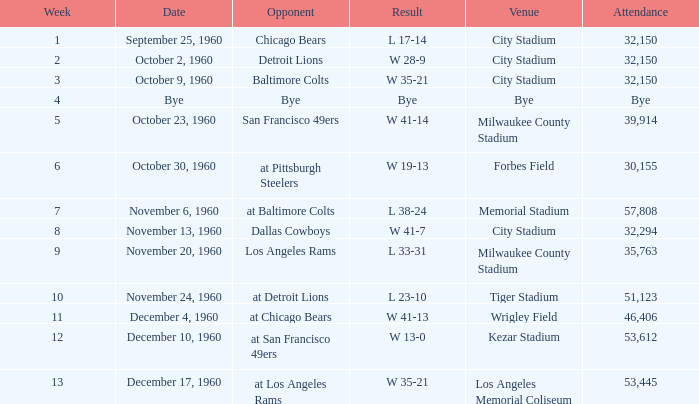What number of people went to the tiger stadium L 23-10. 